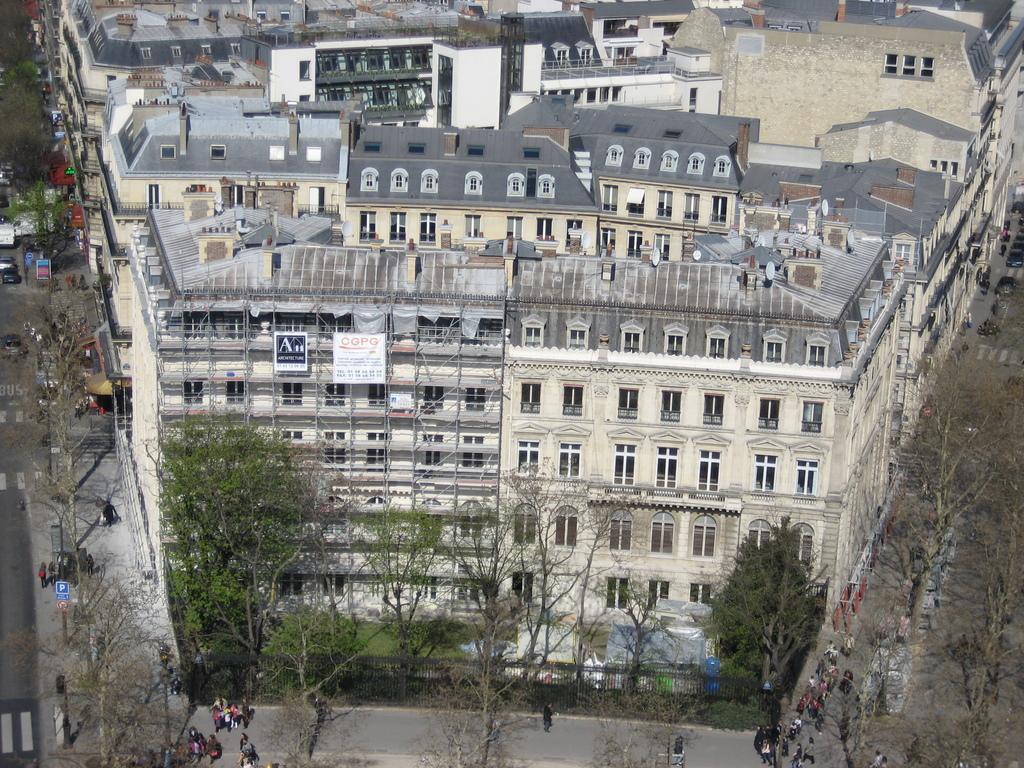Can you describe this image briefly? This image consists of buildings. At the bottom, there are people walking on the road. And there are vehicles. In the front, there are trees. At the bottom, there is a road. 